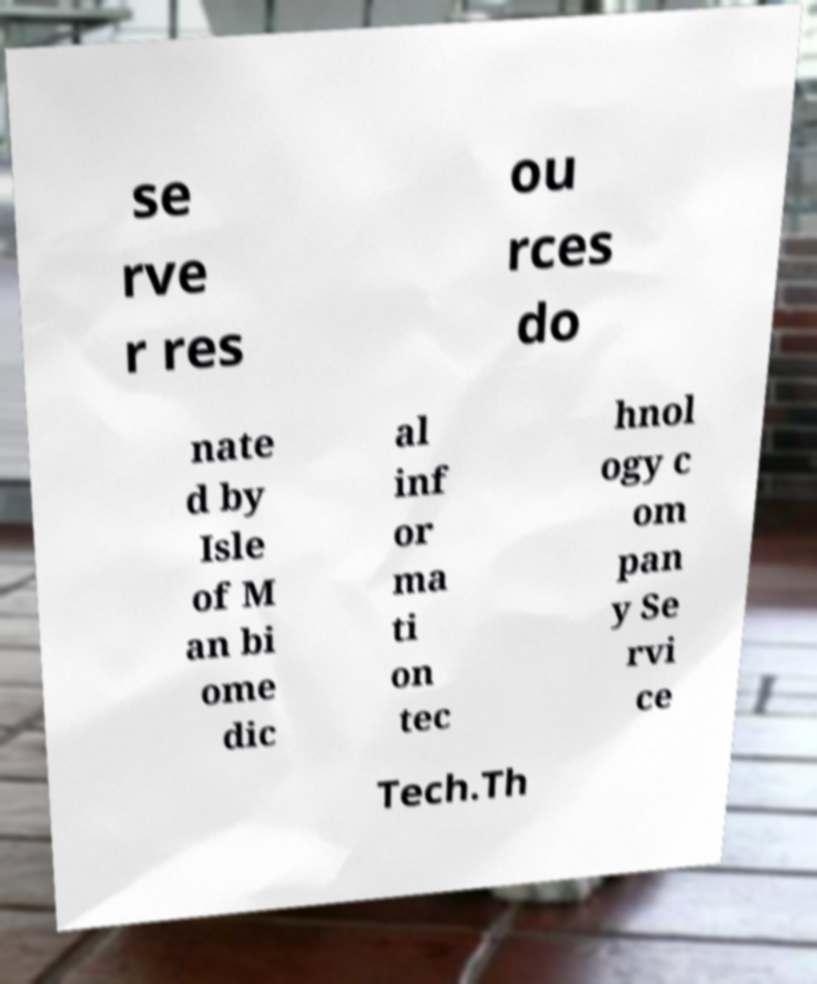I need the written content from this picture converted into text. Can you do that? se rve r res ou rces do nate d by Isle of M an bi ome dic al inf or ma ti on tec hnol ogy c om pan y Se rvi ce Tech.Th 